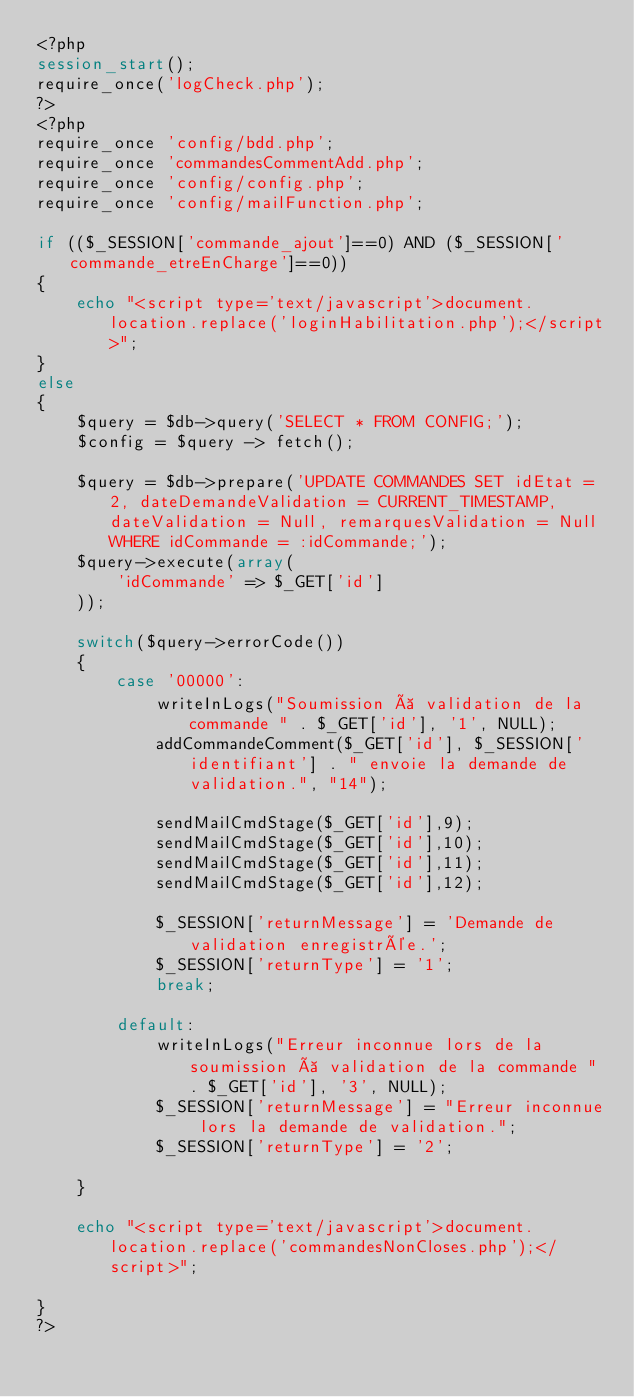<code> <loc_0><loc_0><loc_500><loc_500><_PHP_><?php
session_start();
require_once('logCheck.php');
?>
<?php
require_once 'config/bdd.php';
require_once 'commandesCommentAdd.php';
require_once 'config/config.php';
require_once 'config/mailFunction.php';

if (($_SESSION['commande_ajout']==0) AND ($_SESSION['commande_etreEnCharge']==0))
{
    echo "<script type='text/javascript'>document.location.replace('loginHabilitation.php');</script>";
}
else
{
    $query = $db->query('SELECT * FROM CONFIG;');
    $config = $query -> fetch();

    $query = $db->prepare('UPDATE COMMANDES SET idEtat = 2, dateDemandeValidation = CURRENT_TIMESTAMP, dateValidation = Null, remarquesValidation = Null WHERE idCommande = :idCommande;');
    $query->execute(array(
        'idCommande' => $_GET['id']
    ));

    switch($query->errorCode())
    {
        case '00000':
            writeInLogs("Soumission à validation de la commande " . $_GET['id'], '1', NULL);
            addCommandeComment($_GET['id'], $_SESSION['identifiant'] . " envoie la demande de validation.", "14");

            sendMailCmdStage($_GET['id'],9);
            sendMailCmdStage($_GET['id'],10);
            sendMailCmdStage($_GET['id'],11);
            sendMailCmdStage($_GET['id'],12);

            $_SESSION['returnMessage'] = 'Demande de validation enregistrée.';
            $_SESSION['returnType'] = '1';
            break;

        default:
            writeInLogs("Erreur inconnue lors de la soumission à validation de la commande " . $_GET['id'], '3', NULL);
            $_SESSION['returnMessage'] = "Erreur inconnue lors la demande de validation.";
            $_SESSION['returnType'] = '2';

    }

    echo "<script type='text/javascript'>document.location.replace('commandesNonCloses.php');</script>";

}
?></code> 